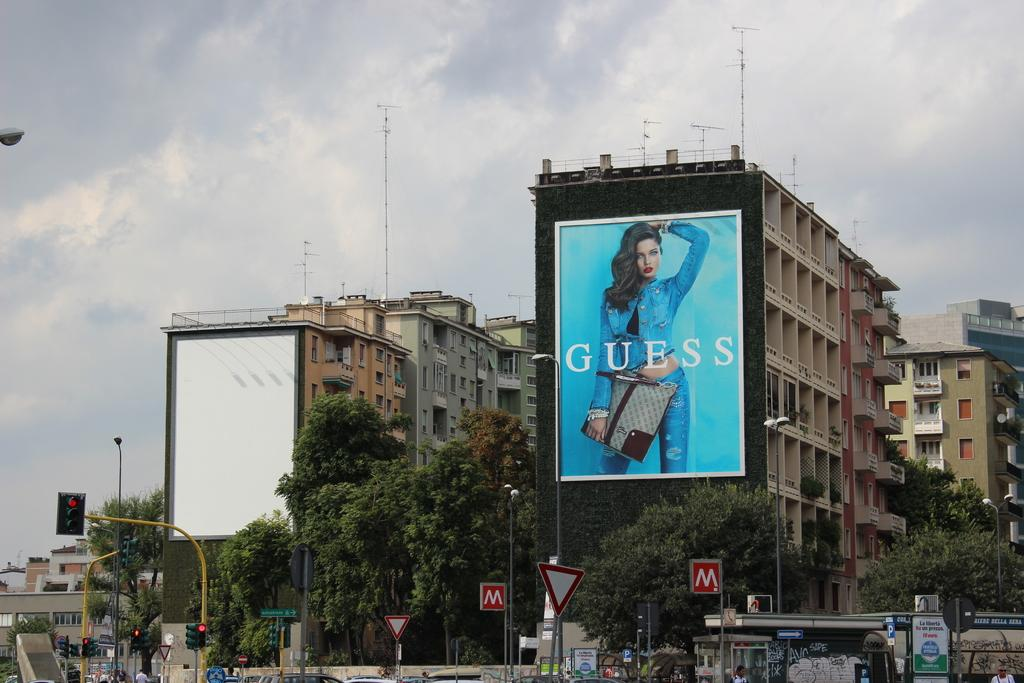<image>
Render a clear and concise summary of the photo. A large ad for Guess is covering an entire apartment building. 